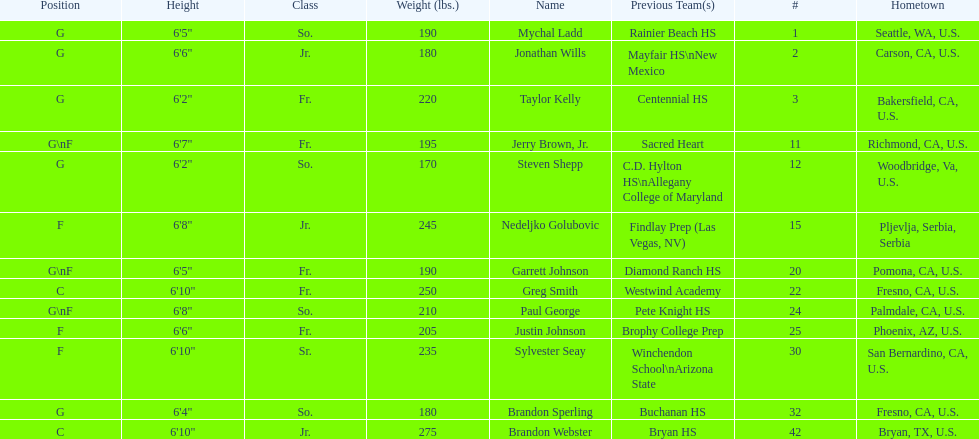How many players and both guard (g) and forward (f)? 3. 